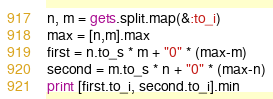Convert code to text. <code><loc_0><loc_0><loc_500><loc_500><_Ruby_>n, m = gets.split.map(&:to_i)
max = [n,m].max
first = n.to_s * m + "0" * (max-m)
second = m.to_s * n + "0" * (max-n)
print [first.to_i, second.to_i].min</code> 